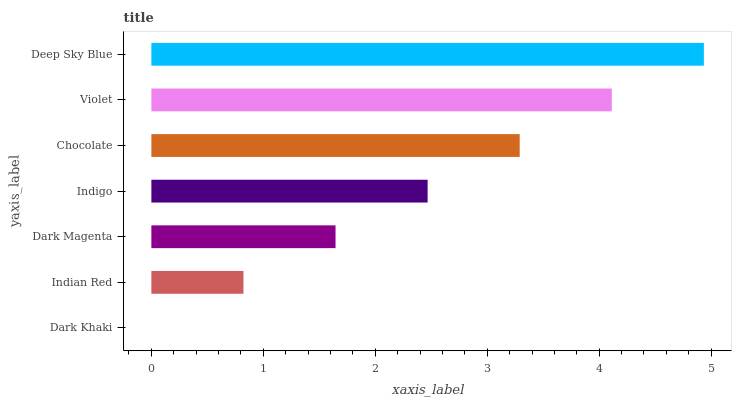Is Dark Khaki the minimum?
Answer yes or no. Yes. Is Deep Sky Blue the maximum?
Answer yes or no. Yes. Is Indian Red the minimum?
Answer yes or no. No. Is Indian Red the maximum?
Answer yes or no. No. Is Indian Red greater than Dark Khaki?
Answer yes or no. Yes. Is Dark Khaki less than Indian Red?
Answer yes or no. Yes. Is Dark Khaki greater than Indian Red?
Answer yes or no. No. Is Indian Red less than Dark Khaki?
Answer yes or no. No. Is Indigo the high median?
Answer yes or no. Yes. Is Indigo the low median?
Answer yes or no. Yes. Is Indian Red the high median?
Answer yes or no. No. Is Dark Khaki the low median?
Answer yes or no. No. 